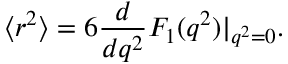Convert formula to latex. <formula><loc_0><loc_0><loc_500><loc_500>\langle r ^ { 2 } \rangle = 6 \frac { d } { d q ^ { 2 } } F _ { 1 } ( q ^ { 2 } ) | _ { q ^ { 2 } = 0 } .</formula> 